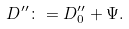Convert formula to latex. <formula><loc_0><loc_0><loc_500><loc_500>D ^ { \prime \prime } \colon = D _ { 0 } ^ { \prime \prime } + \Psi .</formula> 